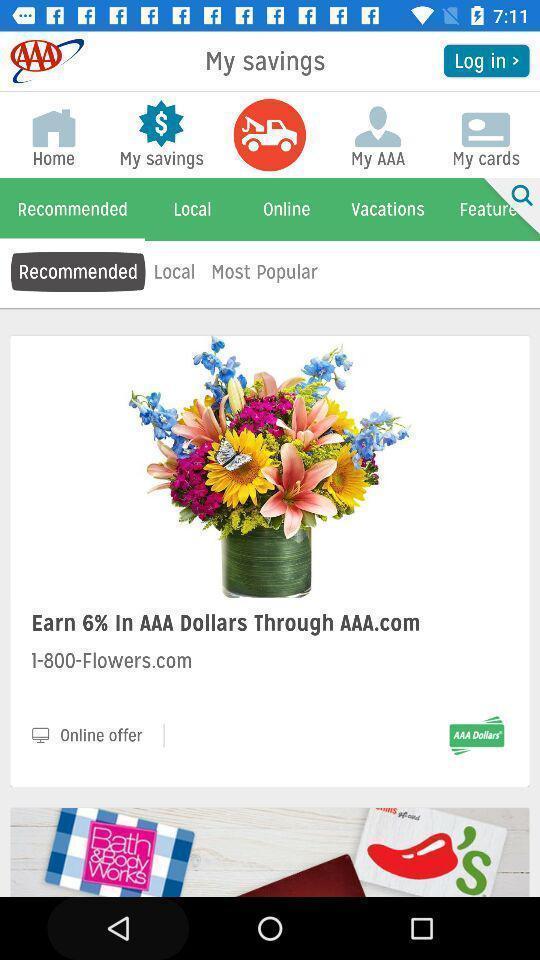What is the overall content of this screenshot? Page showing different options and products on an app. 